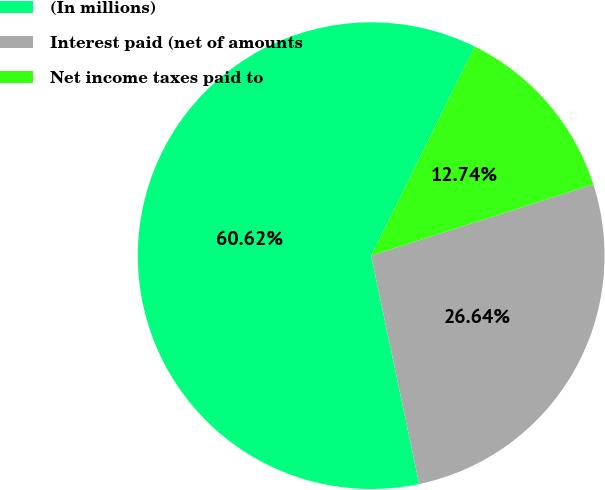<chart> <loc_0><loc_0><loc_500><loc_500><pie_chart><fcel>(In millions)<fcel>Interest paid (net of amounts<fcel>Net income taxes paid to<nl><fcel>60.62%<fcel>26.64%<fcel>12.74%<nl></chart> 